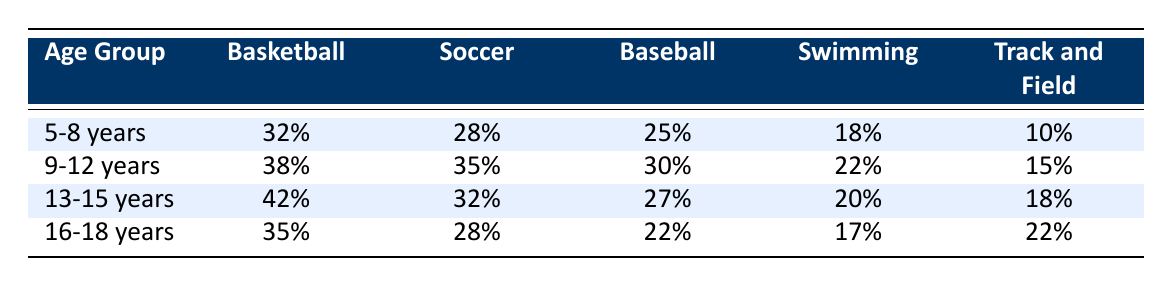What is the percentage of 5-8 year olds participating in swimming? The participation rate for 5-8 year olds in swimming is shown in the table as 18%.
Answer: 18% Which sport has the highest participation rate for the age group 9-12 years? In the age group 9-12 years, basketball has the highest participation rate at 38%.
Answer: 38% What is the difference in percentage points between basketball participation for 13-15 years and 16-18 years? The participation rate for basketball in 13-15 years is 42%, and in 16-18 years, it is 35%. The difference is 42% - 35% = 7 percentage points.
Answer: 7 Is it true that soccer has a higher participation rate for 9-12 years than for 5-8 years? Yes, soccer participation for 9-12 years is 35%, while it is 28% for 5-8 years, confirming the statement is true.
Answer: Yes What is the average participation rate in track and field across all age groups? To calculate the average, we sum the percentages for track and field: 10% + 15% + 18% + 22% = 65%, and then divide by 4 (the number of age groups), giving us 65% / 4 = 16.25%.
Answer: 16.25% 